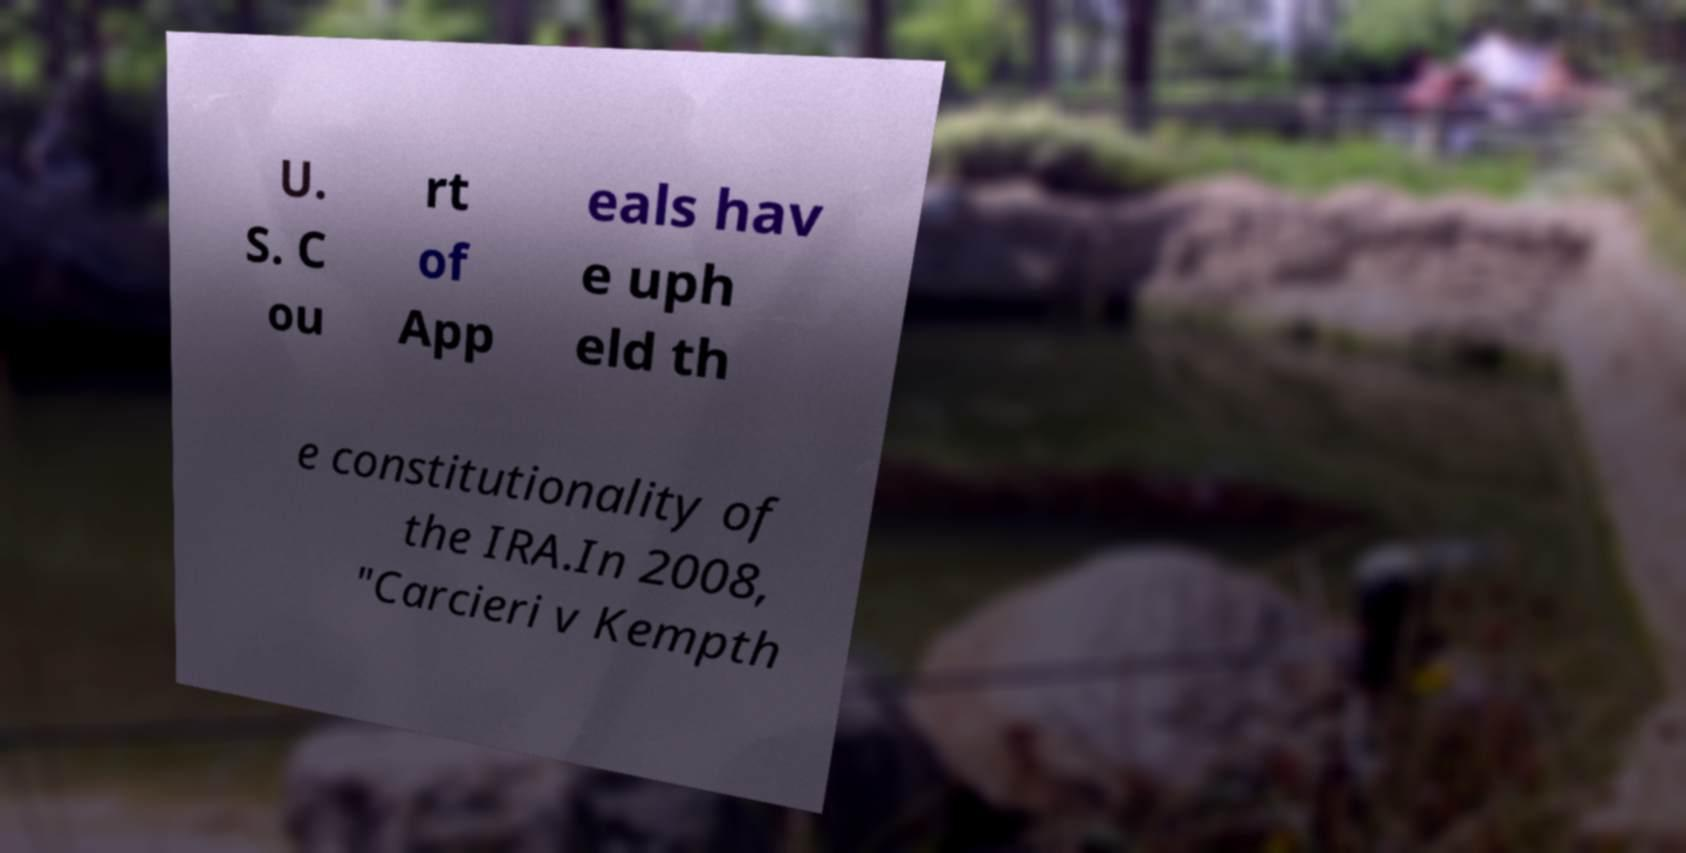Could you extract and type out the text from this image? U. S. C ou rt of App eals hav e uph eld th e constitutionality of the IRA.In 2008, "Carcieri v Kempth 